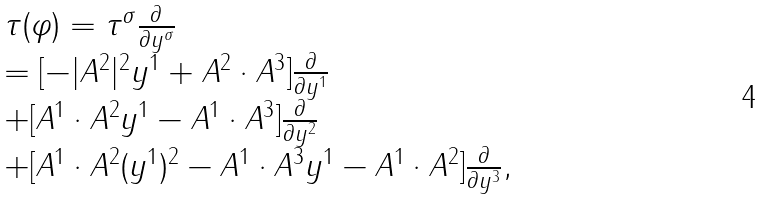Convert formula to latex. <formula><loc_0><loc_0><loc_500><loc_500>\begin{array} { l l l } \tau ( \varphi ) = \tau ^ { \sigma } \frac { \partial } { \partial y ^ { \sigma } } \\ = [ - | A ^ { 2 } | ^ { 2 } y ^ { 1 } + A ^ { 2 } \cdot A ^ { 3 } ] \frac { \partial } { \partial y ^ { 1 } } \\ + [ A ^ { 1 } \cdot A ^ { 2 } y ^ { 1 } - A ^ { 1 } \cdot A ^ { 3 } ] \frac { \partial } { \partial y ^ { 2 } } \\ + [ A ^ { 1 } \cdot A ^ { 2 } ( y ^ { 1 } ) ^ { 2 } - A ^ { 1 } \cdot A ^ { 3 } y ^ { 1 } - A ^ { 1 } \cdot A ^ { 2 } ] \frac { \partial } { \partial y ^ { 3 } } , \\ \end{array}</formula> 